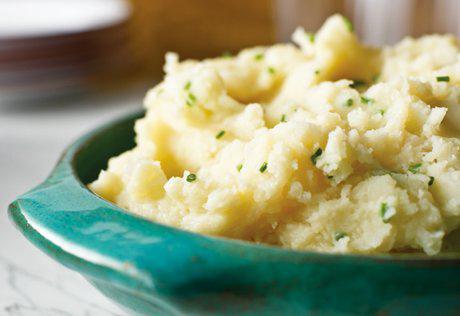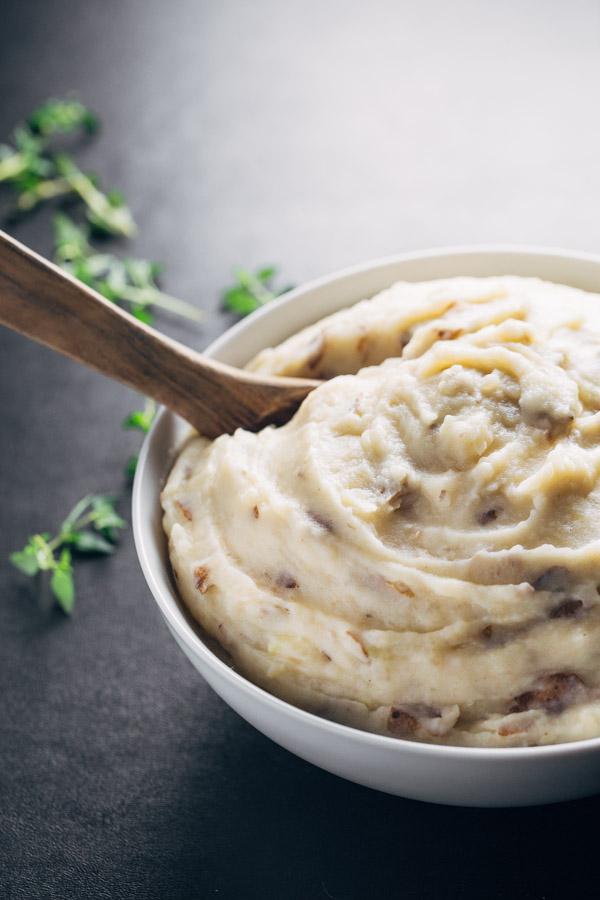The first image is the image on the left, the second image is the image on the right. Analyze the images presented: Is the assertion "An image shows mashed potatoes garnished with chives and served in an olive-green bowl." valid? Answer yes or no. No. The first image is the image on the left, the second image is the image on the right. Examine the images to the left and right. Is the description "The food in the image on the right  is in a green bowl." accurate? Answer yes or no. No. 